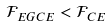Convert formula to latex. <formula><loc_0><loc_0><loc_500><loc_500>\mathcal { F } _ { E G C E } < \mathcal { F } _ { C E }</formula> 